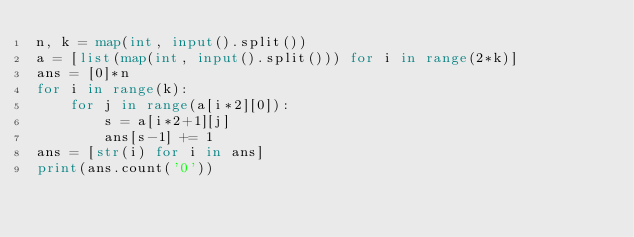Convert code to text. <code><loc_0><loc_0><loc_500><loc_500><_Python_>n, k = map(int, input().split())
a = [list(map(int, input().split())) for i in range(2*k)]
ans = [0]*n
for i in range(k):
    for j in range(a[i*2][0]):
        s = a[i*2+1][j]
        ans[s-1] += 1
ans = [str(i) for i in ans]
print(ans.count('0'))</code> 